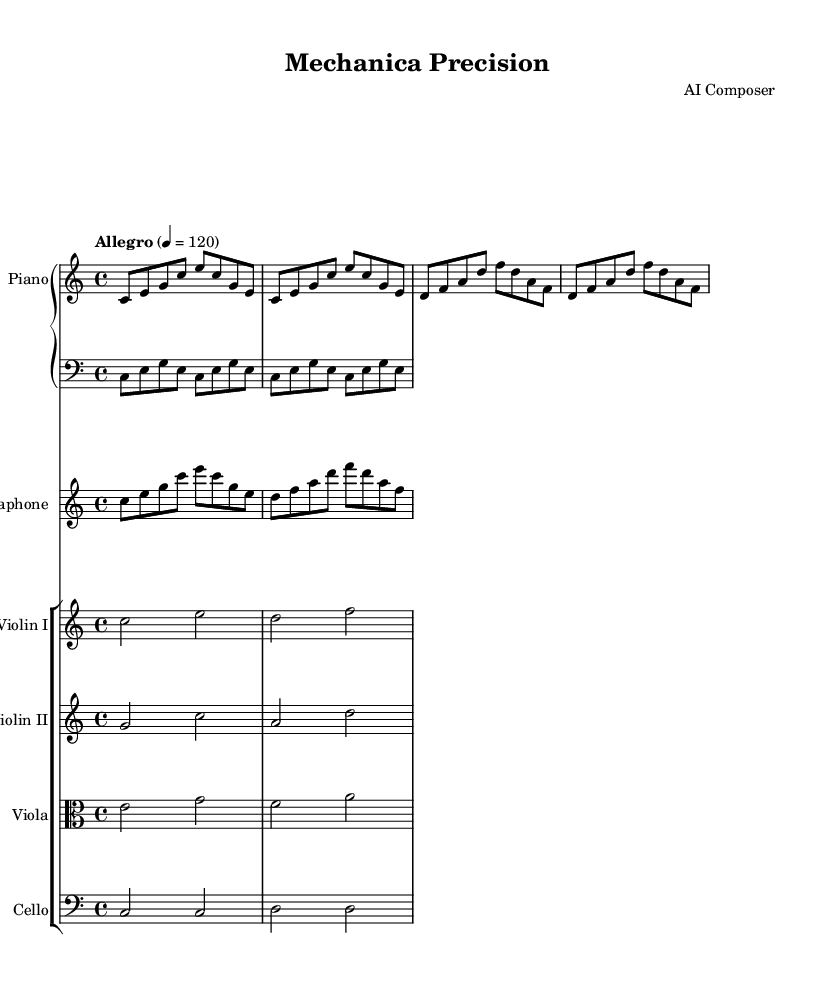What is the key signature of this music? The key signature is C major, which has no sharps or flats. Therefore, it is visually identified by the absence of any sharps or flats in the key signature at the start.
Answer: C major What is the time signature of this music? The time signature is 4/4, indicated at the beginning of the score. Each measure contains four beats, and the quarter note gets one beat, which can be confirmed by counting the note values.
Answer: 4/4 What is the tempo marking of the composition? The tempo marking is "Allegro" with a metronome marking of quarter note = 120. This is found at the top of the score, where tempo instructions are typically placed because they dictate the speed of the piece.
Answer: Allegro, 120 How many measures are in the piano right hand part? The piano right hand part has 8 measures. This can be determined by counting the number of groups of beats divided by vertical lines (bar lines) found throughout the staff.
Answer: 8 What is the highest pitch instrument in this score? The highest pitch instrument in this score is the Violin I. By looking at the pitches written on the staff, the Violin I part shows notes higher than those in the other instruments, confirming it plays the highest notes.
Answer: Violin I What type of texture is predominantly used in "Mechanica Precision"? The texture is primarily homophonic, which means that it features a clear melodic line (in the solo instruments) supported by harmonic accompaniment (the piano and other strings). This can be inferred from the arrangement of instruments focused on melody and harmony together.
Answer: Homophonic Which instrument plays the repeated motif throughout the composition? The piano right hand (RH) plays the repeated motif throughout the composition. When analyzing the music, we can see that the RH part has a specific sequence that is restated multiple times, demonstrating a key characteristic of minimalism.
Answer: Piano right hand 